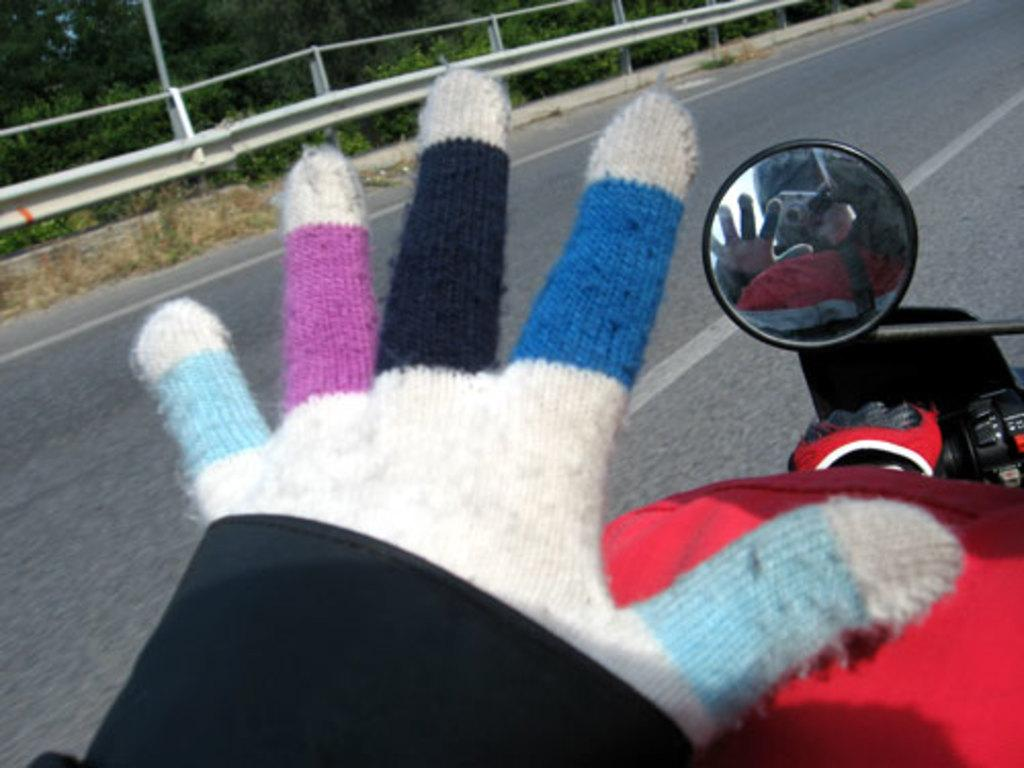What type of clothing item is present in the image? There are hand gloves in the image. What object is typically used for personal grooming and reflection? There is a mirror in the image. What can be seen in the background of the image? There is a road visible in the image. What type of vegetation is present in the image? There are trees in the image. What is the name of the daughter in the image? There is no daughter present in the image. How does the fowl interact with the hand gloves in the image? There is no fowl present in the image, so it cannot interact with the hand gloves. 